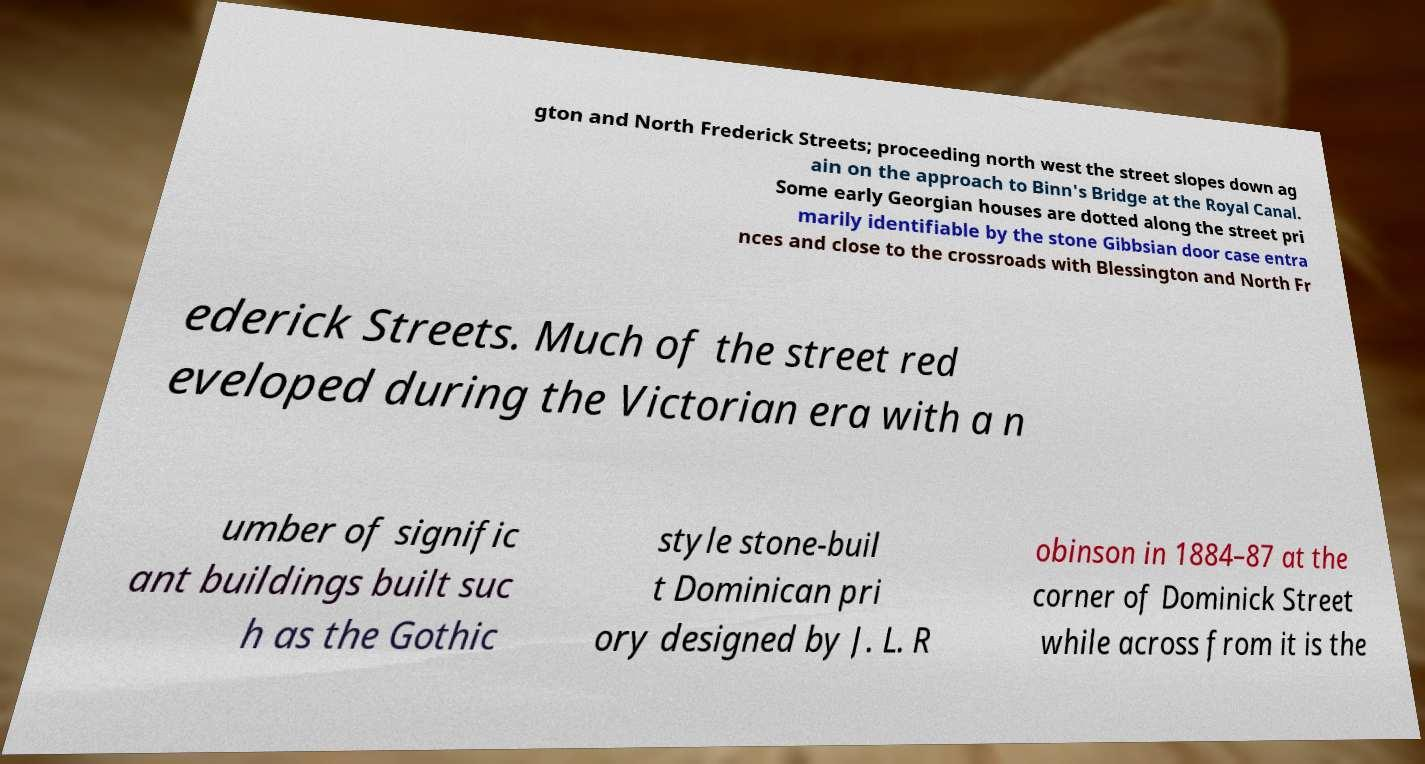Please read and relay the text visible in this image. What does it say? gton and North Frederick Streets; proceeding north west the street slopes down ag ain on the approach to Binn's Bridge at the Royal Canal. Some early Georgian houses are dotted along the street pri marily identifiable by the stone Gibbsian door case entra nces and close to the crossroads with Blessington and North Fr ederick Streets. Much of the street red eveloped during the Victorian era with a n umber of signific ant buildings built suc h as the Gothic style stone-buil t Dominican pri ory designed by J. L. R obinson in 1884–87 at the corner of Dominick Street while across from it is the 